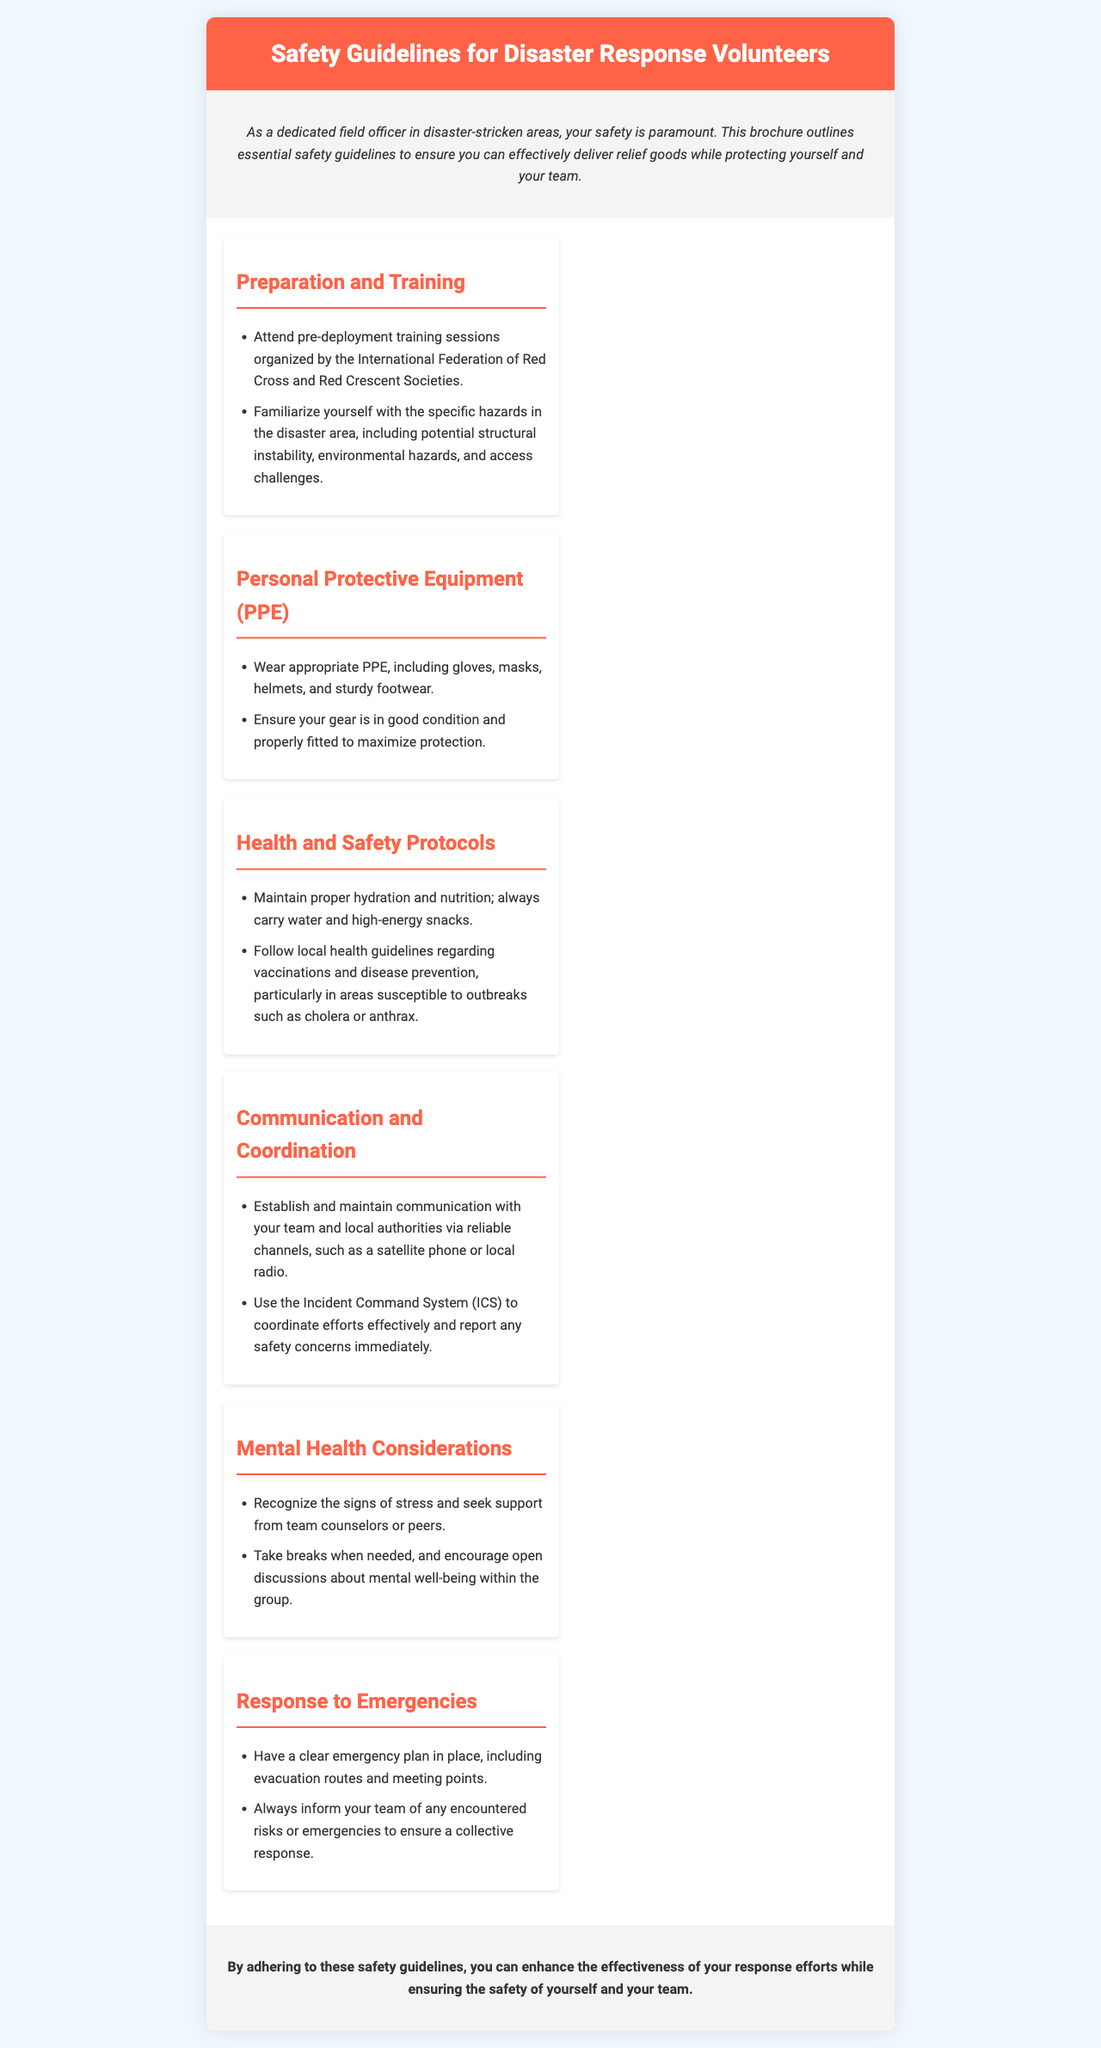what is the title of the brochure? The title of the brochure is prominently displayed in the header section of the document.
Answer: Safety Guidelines for Disaster Response Volunteers how many sections are there in the content? The document lists several distinct topics under content, each representing a section.
Answer: Six what should you carry to maintain proper health? The document specifically mentions what to take for hydration and nutrition.
Answer: Water and high-energy snacks what equipment should volunteers wear? The document notes the type of protective gear required for safety.
Answer: PPE, including gloves, masks, helmets, and sturdy footwear which system should be used for coordination? The document refers to a specific system for coordinating efforts among volunteers.
Answer: Incident Command System (ICS) what should you do if you recognize stress signs? The document advises on actions to take if stress is detected among team members.
Answer: Seek support from team counselors or peers what is the emergency planning requirement mentioned? The document highlights a necessity for dealing with unforeseen situations.
Answer: Have a clear emergency plan who organizes the pre-deployment training sessions? The document states the organization responsible for training before deployment.
Answer: International Federation of Red Cross and Red Crescent Societies 